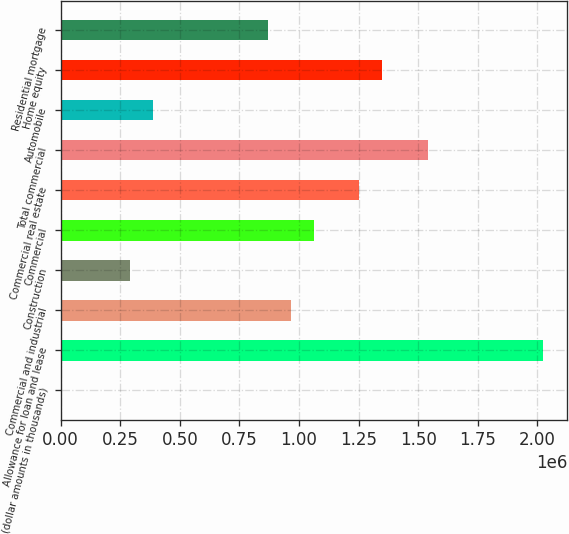<chart> <loc_0><loc_0><loc_500><loc_500><bar_chart><fcel>(dollar amounts in thousands)<fcel>Allowance for loan and lease<fcel>Commercial and industrial<fcel>Construction<fcel>Commercial<fcel>Commercial real estate<fcel>Total commercial<fcel>Automobile<fcel>Home equity<fcel>Residential mortgage<nl><fcel>2012<fcel>2.02393e+06<fcel>964828<fcel>290857<fcel>1.06111e+06<fcel>1.25367e+06<fcel>1.54252e+06<fcel>387138<fcel>1.34995e+06<fcel>868546<nl></chart> 